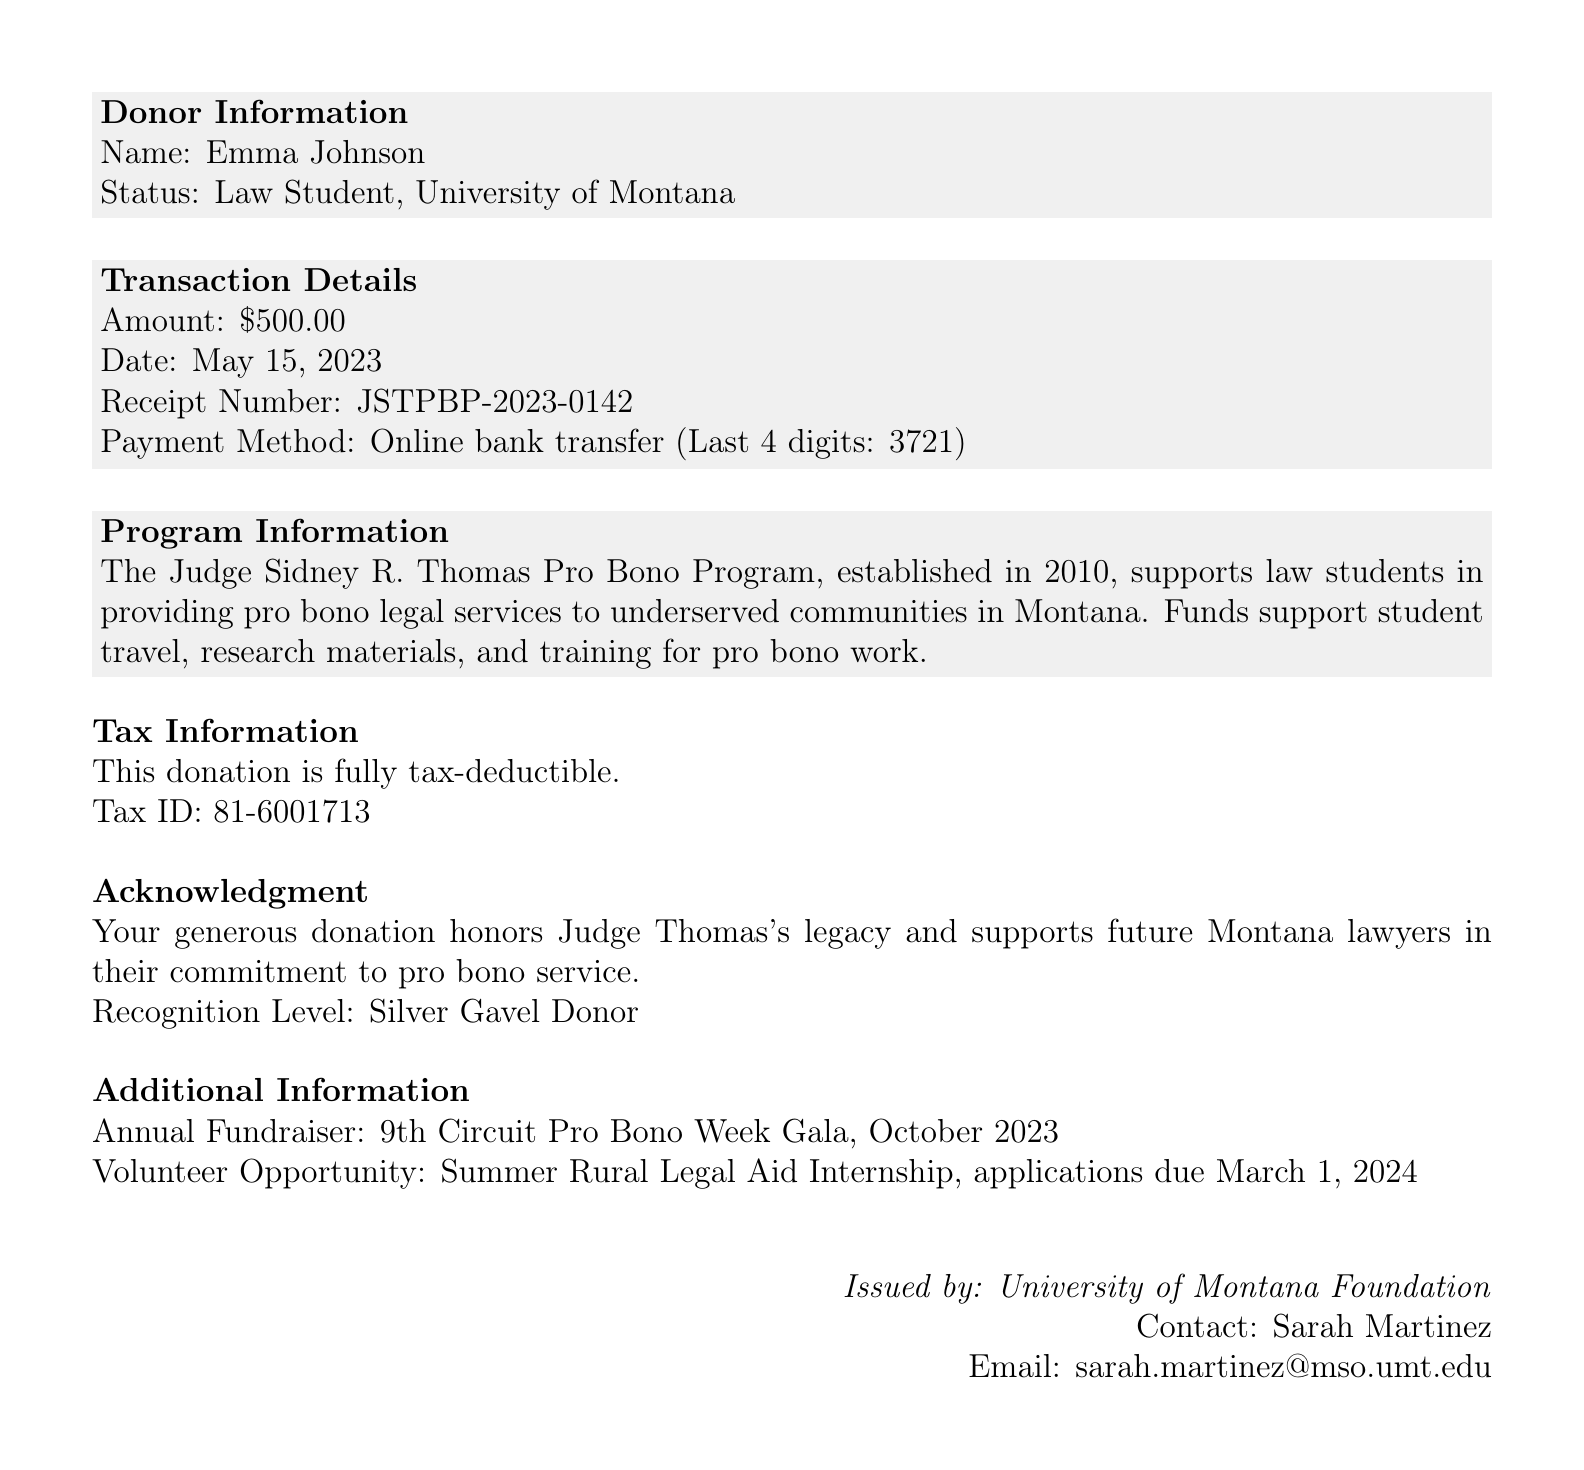What is the donor's name? The document specifies that Emma Johnson is the donor.
Answer: Emma Johnson What is the donation amount? The document states the donation amount is $500.00.
Answer: $500.00 When was the donation made? The document provides the date of the donation as May 15, 2023.
Answer: May 15, 2023 What is the tax-deductible status of the donation? The document indicates the status as fully tax-deductible.
Answer: Fully tax-deductible What program does the donation support? The document identifies the program supported as the Judge Sidney R. Thomas Pro Bono Program.
Answer: Judge Sidney R. Thomas Pro Bono Program Who issued the receipt? The receipt is issued by the University of Montana Foundation.
Answer: University of Montana Foundation What is the contact person's email? The document mentions the contact email as sarah.martinez@mso.umt.edu.
Answer: sarah.martinez@mso.umt.edu What is the recognition level for this donation? The document states the recognition level as Silver Gavel Donor.
Answer: Silver Gavel Donor What is the purpose of the funds? The document explains that funds support student travel, research materials, and training for pro bono work.
Answer: Student travel, research materials, and training for pro bono work When is the annual fundraiser scheduled? According to the document, the annual fundraiser is the 9th Circuit Pro Bono Week Gala, scheduled for October 2023.
Answer: October 2023 